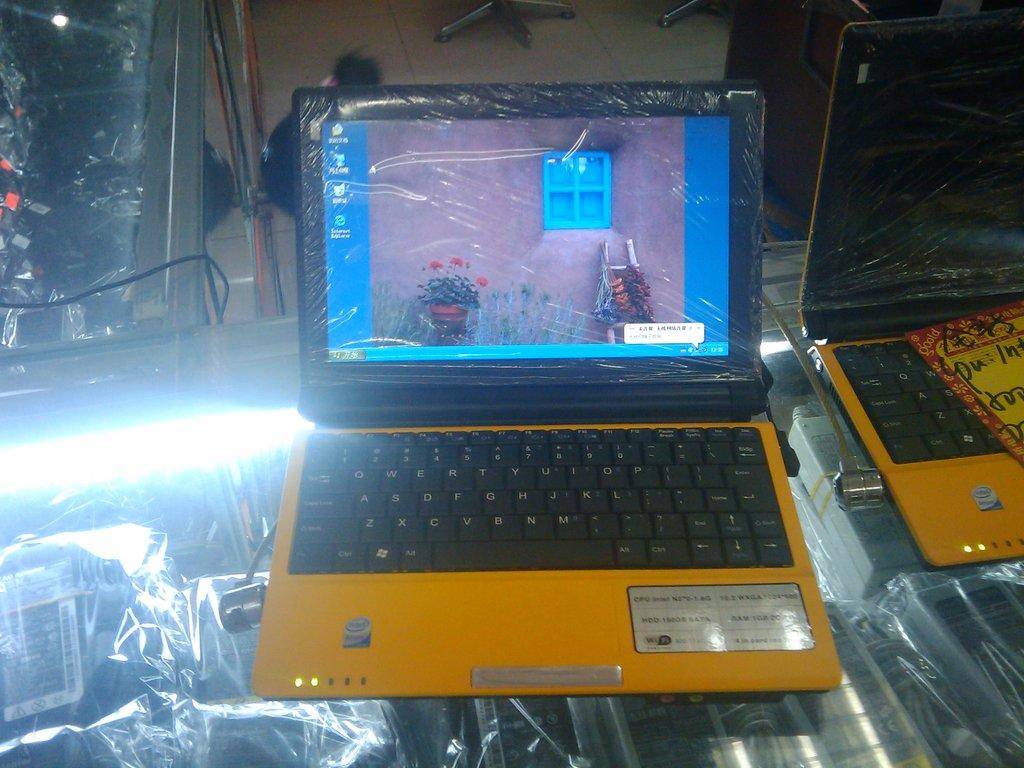Is wi-fi listed on the specification sheet on the computer label?
Your response must be concise. Yes. 